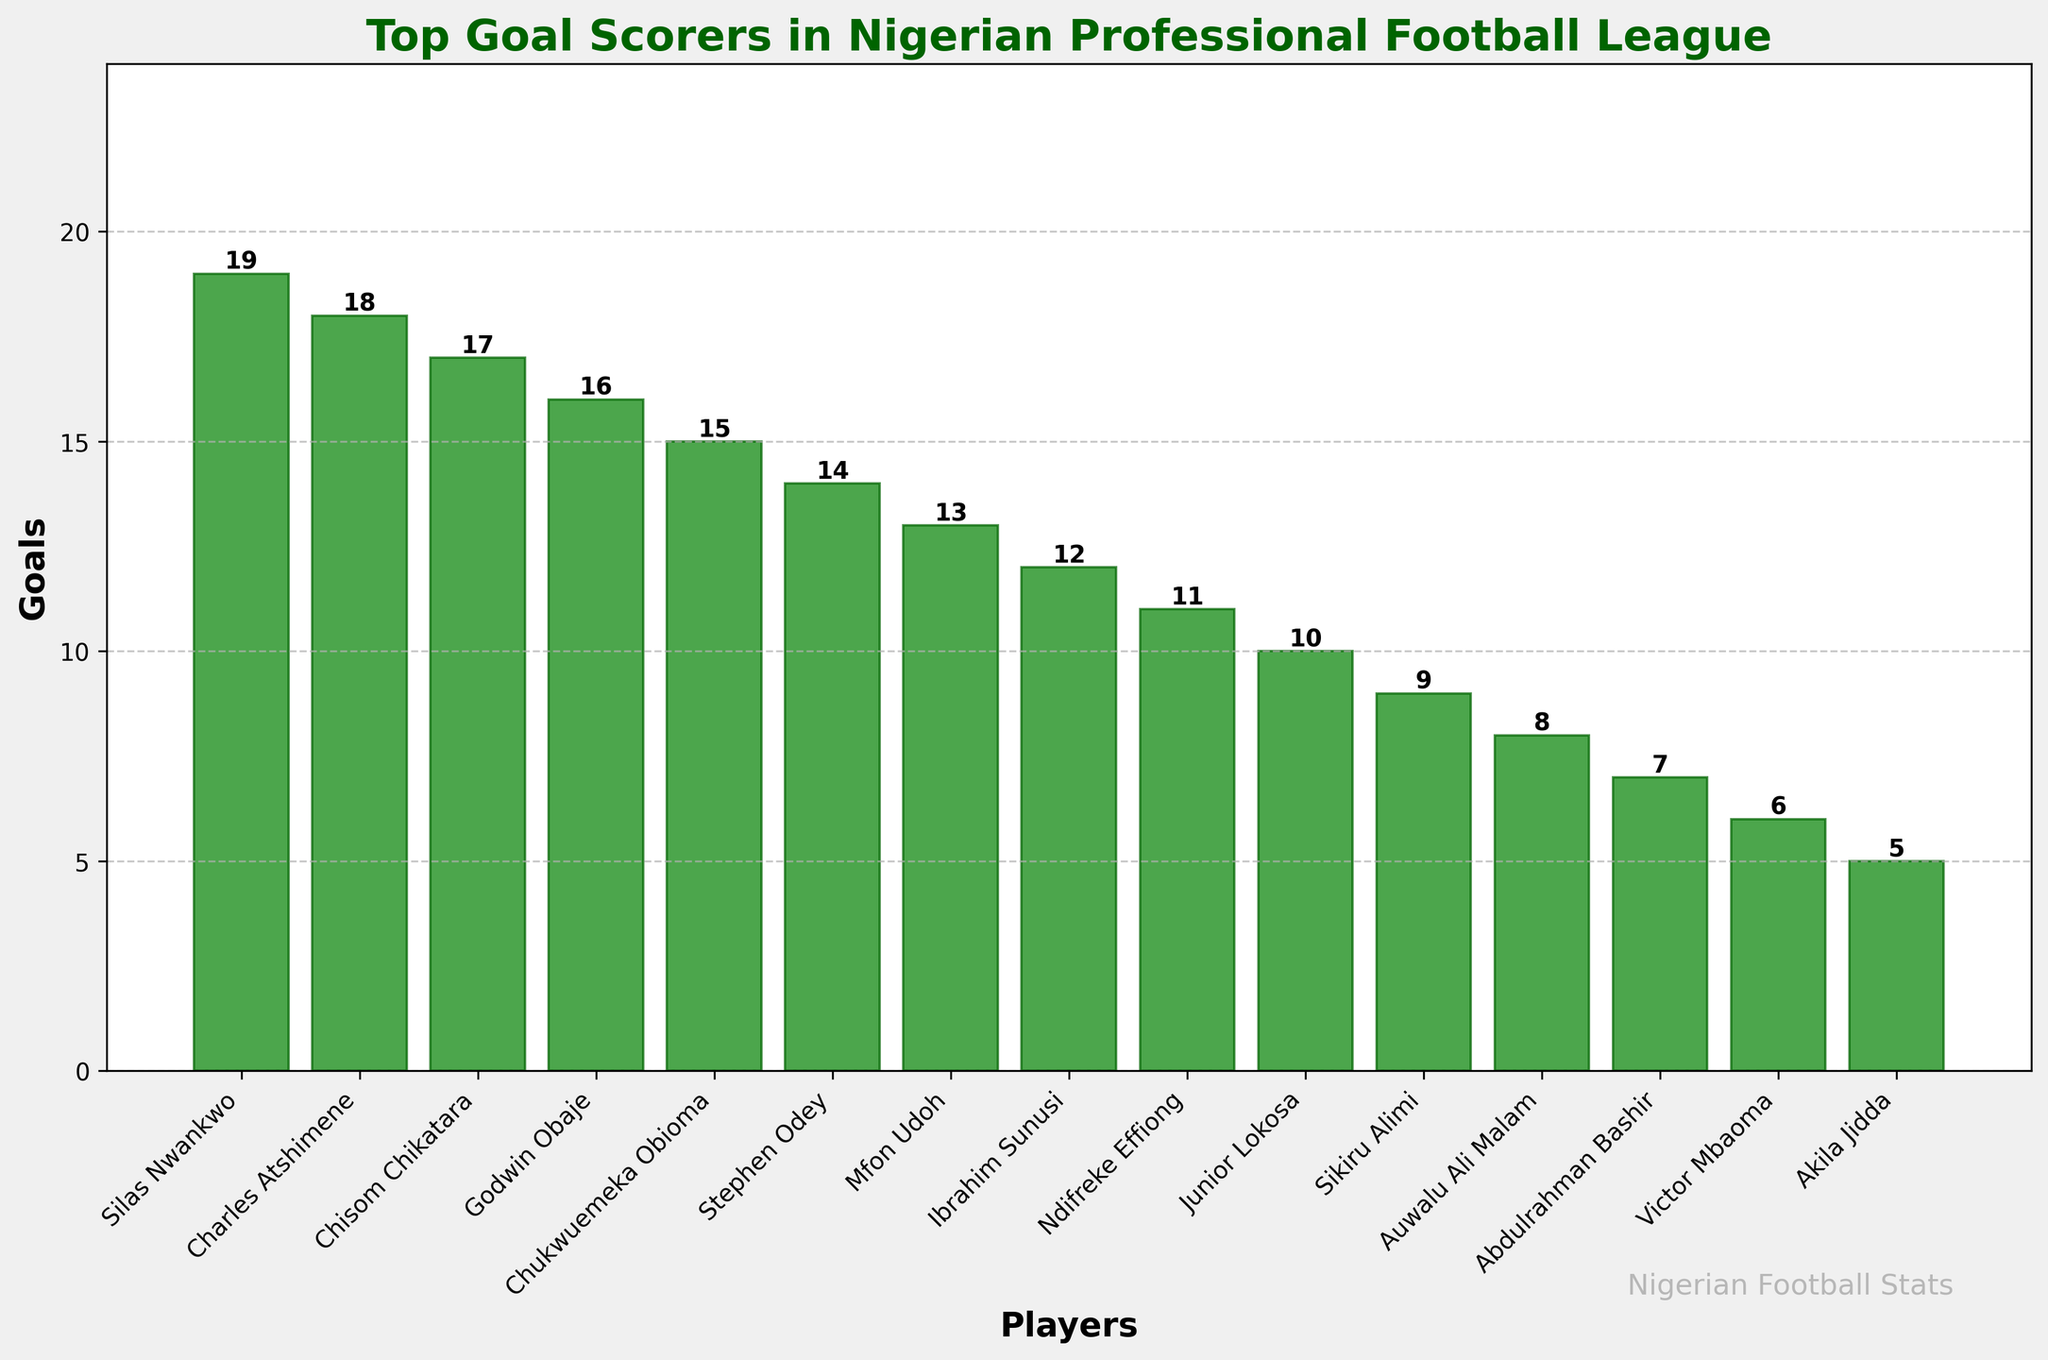Which player scored the most goals in the Nigerian Professional Football League in the last 5 seasons? Silas Nwankwo has the highest bar in the chart, indicating he scored the most goals.
Answer: Silas Nwankwo How many goals separate Silas Nwankwo and Charles Atshimene? Silas Nwankwo scored 19 goals and Charles Atshimene scored 18 goals. The difference is 19 - 18.
Answer: 1 Who is the third-highest goal scorer, and how many goals did he score? The third-highest goal scorer is Chisom Chikatara, as his bar is the third highest, with 17 goals.
Answer: Chisom Chikatara, 17 What is the total number of goals scored by the top 3 players? Silas Nwankwo scored 19 goals, Charles Atshimene scored 18 goals, and Chisom Chikatara scored 17 goals. The total is 19 + 18 + 17.
Answer: 54 How many players scored more than 12 goals? Silas Nwankwo, Charles Atshimene, Chisom Chikatara, Godwin Obaje, Chukwuemeka Obioma, and Stephen Odey all scored more than 12 goals. Count these players.
Answer: 6 Which player scored 9 goals, and how does this rank among the top scorers? Sikiru Alimi scored 9 goals, which ranks him 11th among all listed players.
Answer: Sikiru Alimi, 11th What is the average number of goals scored by the players who scored less than 10 goals? Players scoring less than 10 goals are Abdulrahman Bashir, Victor Mbaoma, and Akila Jidda. Their goals are 7, 6, and 5 respectively. The average is (7 + 6 + 5) / 3.
Answer: 6 What is the median number of goals scored by all players listed? To find the median, first list all goal counts: 19, 18, 17, 16, 15, 14, 13, 12, 11, 10, 9, 8, 7, 6, 5. The median is the middle value of the ordered list.
Answer: 12 Compare the goals scored by Silas Nwankwo and Junior Lokosa. Who scored more and by how many? Silas Nwankwo scored 19 goals, while Junior Lokosa scored 10. The difference is 19 - 10.
Answer: Silas Nwankwo by 9 goals How many goals did the players scoring exactly 11 and 13 goals make in total? Ndifreke Effiong scored 11 goals and Mfon Udoh scored 13 goals. The total is 11 + 13.
Answer: 24 